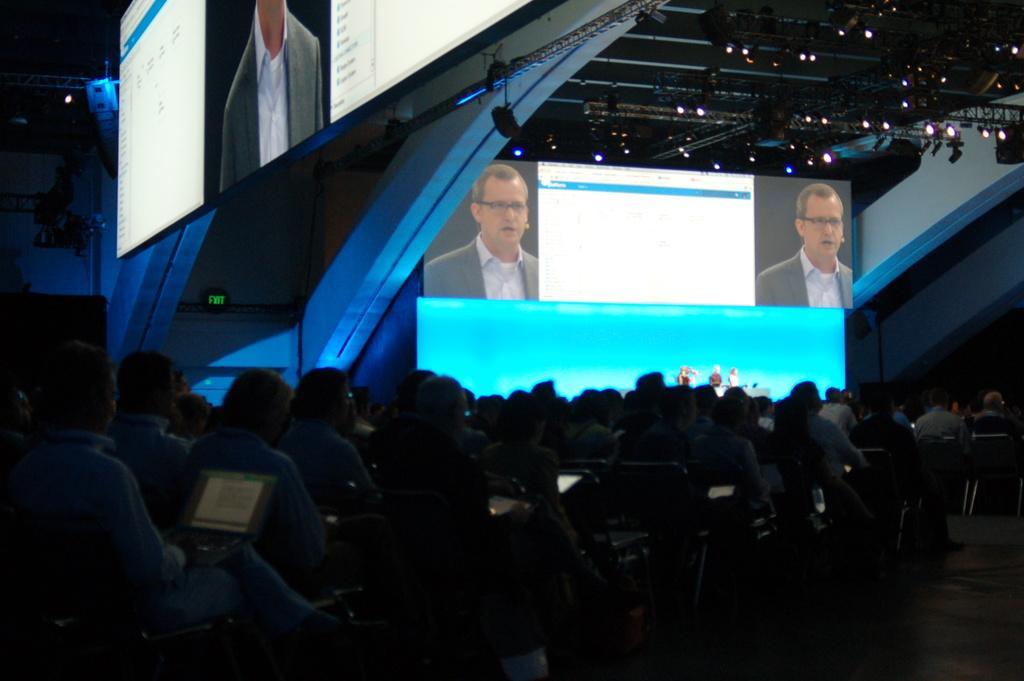Describe this image in one or two sentences. In this image at the bottom there are many people sitting. On the left there is a man, he is sitting on the chair. At the top there are some people, screens, lights, stage, wall. 